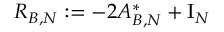Convert formula to latex. <formula><loc_0><loc_0><loc_500><loc_500>R _ { B , N } \colon = - 2 A _ { B , N } ^ { * } + I _ { N }</formula> 